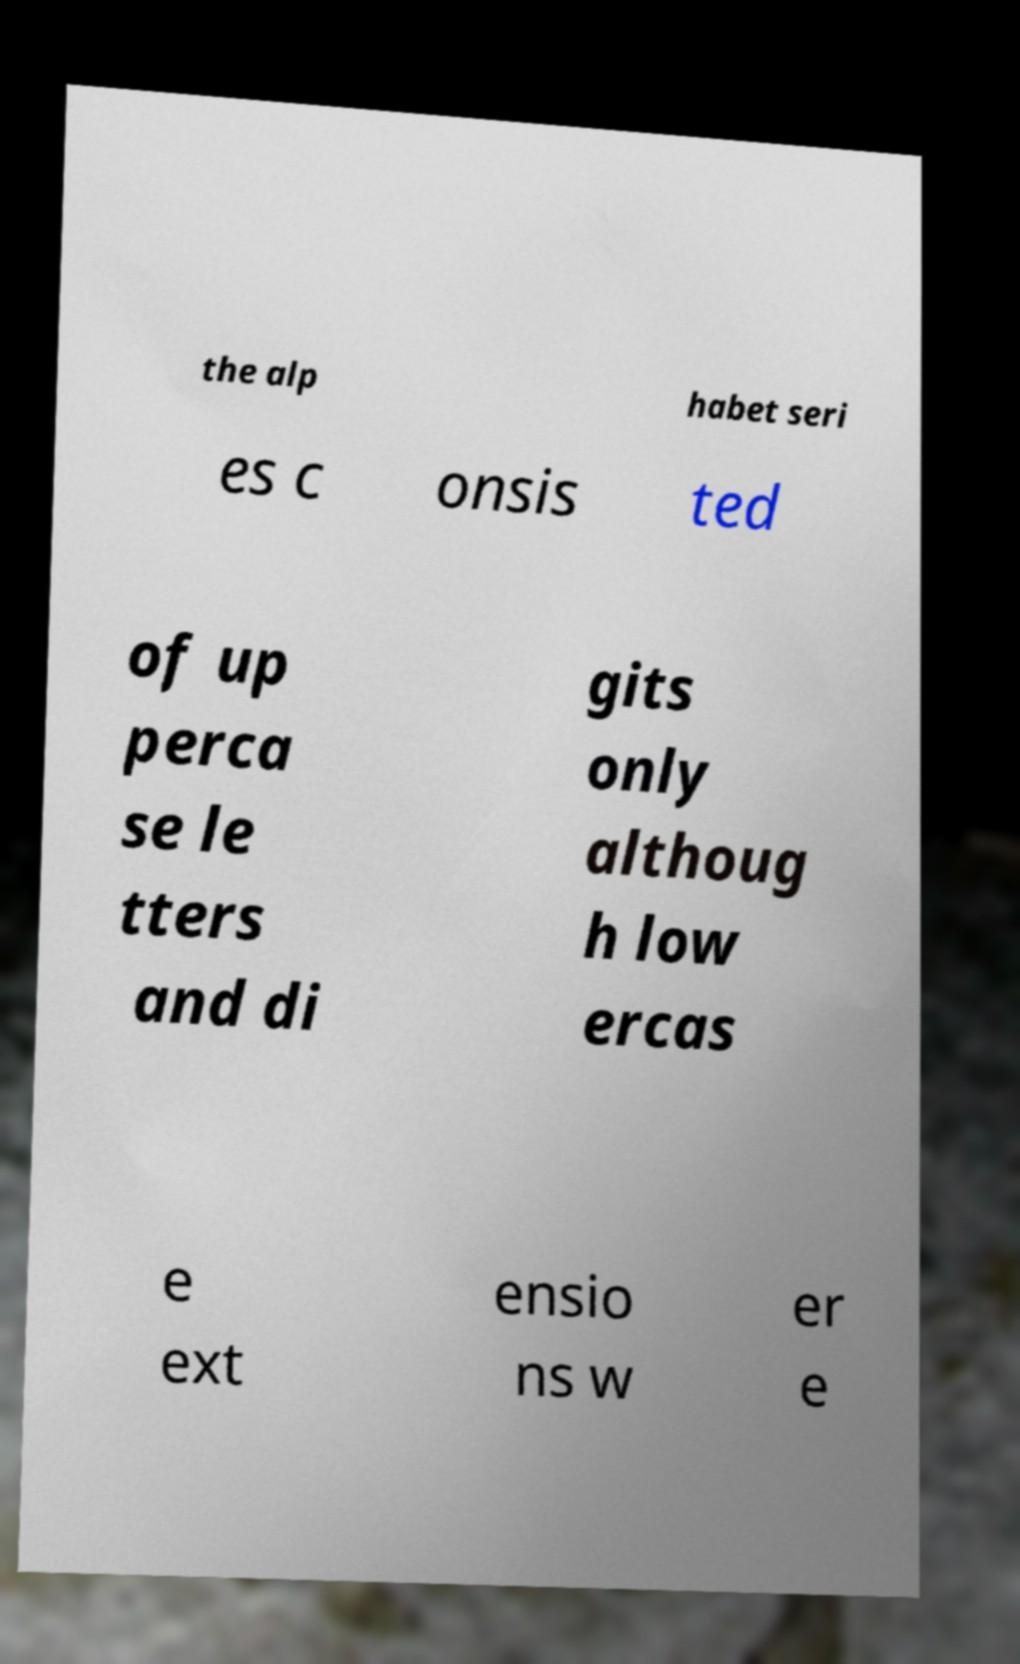Please read and relay the text visible in this image. What does it say? the alp habet seri es c onsis ted of up perca se le tters and di gits only althoug h low ercas e ext ensio ns w er e 